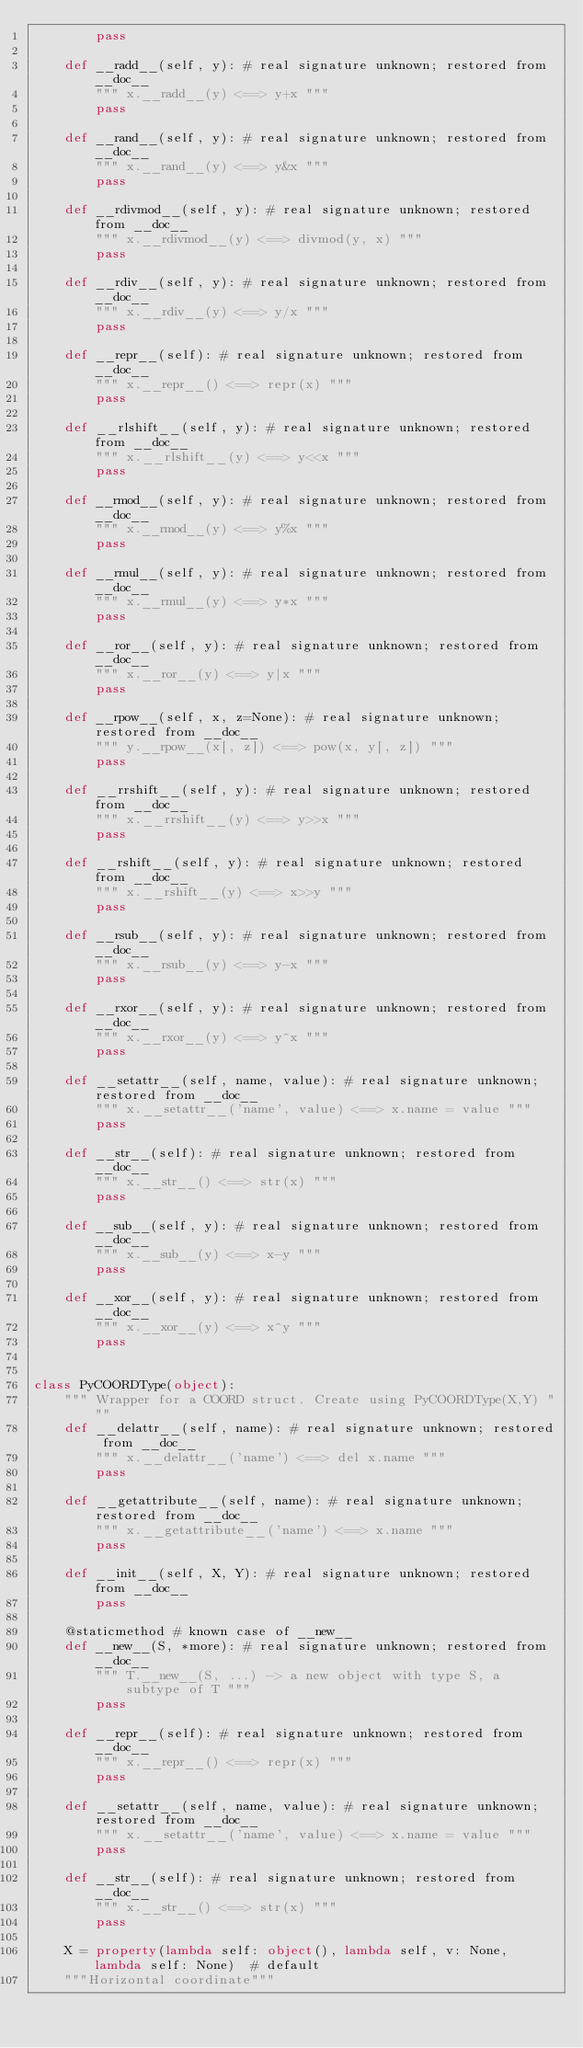Convert code to text. <code><loc_0><loc_0><loc_500><loc_500><_Python_>        pass

    def __radd__(self, y): # real signature unknown; restored from __doc__
        """ x.__radd__(y) <==> y+x """
        pass

    def __rand__(self, y): # real signature unknown; restored from __doc__
        """ x.__rand__(y) <==> y&x """
        pass

    def __rdivmod__(self, y): # real signature unknown; restored from __doc__
        """ x.__rdivmod__(y) <==> divmod(y, x) """
        pass

    def __rdiv__(self, y): # real signature unknown; restored from __doc__
        """ x.__rdiv__(y) <==> y/x """
        pass

    def __repr__(self): # real signature unknown; restored from __doc__
        """ x.__repr__() <==> repr(x) """
        pass

    def __rlshift__(self, y): # real signature unknown; restored from __doc__
        """ x.__rlshift__(y) <==> y<<x """
        pass

    def __rmod__(self, y): # real signature unknown; restored from __doc__
        """ x.__rmod__(y) <==> y%x """
        pass

    def __rmul__(self, y): # real signature unknown; restored from __doc__
        """ x.__rmul__(y) <==> y*x """
        pass

    def __ror__(self, y): # real signature unknown; restored from __doc__
        """ x.__ror__(y) <==> y|x """
        pass

    def __rpow__(self, x, z=None): # real signature unknown; restored from __doc__
        """ y.__rpow__(x[, z]) <==> pow(x, y[, z]) """
        pass

    def __rrshift__(self, y): # real signature unknown; restored from __doc__
        """ x.__rrshift__(y) <==> y>>x """
        pass

    def __rshift__(self, y): # real signature unknown; restored from __doc__
        """ x.__rshift__(y) <==> x>>y """
        pass

    def __rsub__(self, y): # real signature unknown; restored from __doc__
        """ x.__rsub__(y) <==> y-x """
        pass

    def __rxor__(self, y): # real signature unknown; restored from __doc__
        """ x.__rxor__(y) <==> y^x """
        pass

    def __setattr__(self, name, value): # real signature unknown; restored from __doc__
        """ x.__setattr__('name', value) <==> x.name = value """
        pass

    def __str__(self): # real signature unknown; restored from __doc__
        """ x.__str__() <==> str(x) """
        pass

    def __sub__(self, y): # real signature unknown; restored from __doc__
        """ x.__sub__(y) <==> x-y """
        pass

    def __xor__(self, y): # real signature unknown; restored from __doc__
        """ x.__xor__(y) <==> x^y """
        pass


class PyCOORDType(object):
    """ Wrapper for a COORD struct. Create using PyCOORDType(X,Y) """
    def __delattr__(self, name): # real signature unknown; restored from __doc__
        """ x.__delattr__('name') <==> del x.name """
        pass

    def __getattribute__(self, name): # real signature unknown; restored from __doc__
        """ x.__getattribute__('name') <==> x.name """
        pass

    def __init__(self, X, Y): # real signature unknown; restored from __doc__
        pass

    @staticmethod # known case of __new__
    def __new__(S, *more): # real signature unknown; restored from __doc__
        """ T.__new__(S, ...) -> a new object with type S, a subtype of T """
        pass

    def __repr__(self): # real signature unknown; restored from __doc__
        """ x.__repr__() <==> repr(x) """
        pass

    def __setattr__(self, name, value): # real signature unknown; restored from __doc__
        """ x.__setattr__('name', value) <==> x.name = value """
        pass

    def __str__(self): # real signature unknown; restored from __doc__
        """ x.__str__() <==> str(x) """
        pass

    X = property(lambda self: object(), lambda self, v: None, lambda self: None)  # default
    """Horizontal coordinate"""
</code> 